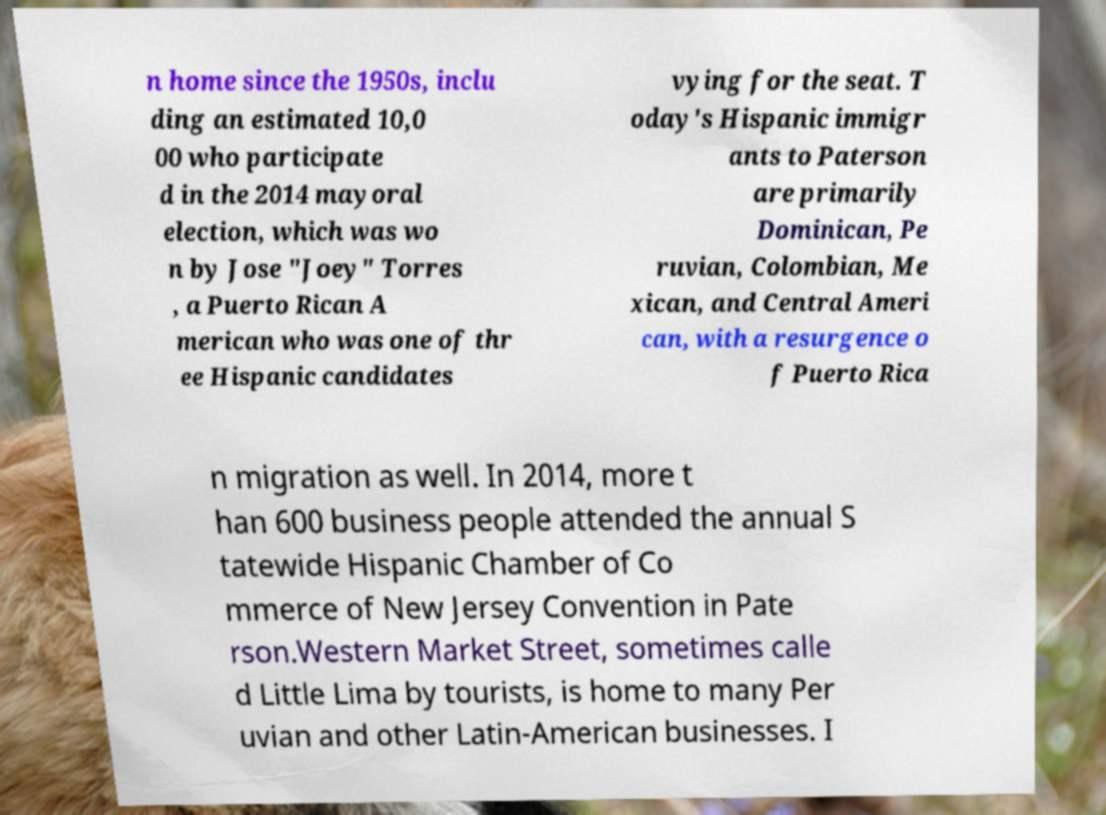Please read and relay the text visible in this image. What does it say? n home since the 1950s, inclu ding an estimated 10,0 00 who participate d in the 2014 mayoral election, which was wo n by Jose "Joey" Torres , a Puerto Rican A merican who was one of thr ee Hispanic candidates vying for the seat. T oday's Hispanic immigr ants to Paterson are primarily Dominican, Pe ruvian, Colombian, Me xican, and Central Ameri can, with a resurgence o f Puerto Rica n migration as well. In 2014, more t han 600 business people attended the annual S tatewide Hispanic Chamber of Co mmerce of New Jersey Convention in Pate rson.Western Market Street, sometimes calle d Little Lima by tourists, is home to many Per uvian and other Latin-American businesses. I 